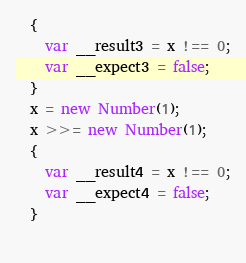<code> <loc_0><loc_0><loc_500><loc_500><_JavaScript_>  {
    var __result3 = x !== 0;
    var __expect3 = false;
  }
  x = new Number(1);
  x >>= new Number(1);
  {
    var __result4 = x !== 0;
    var __expect4 = false;
  }
  </code> 